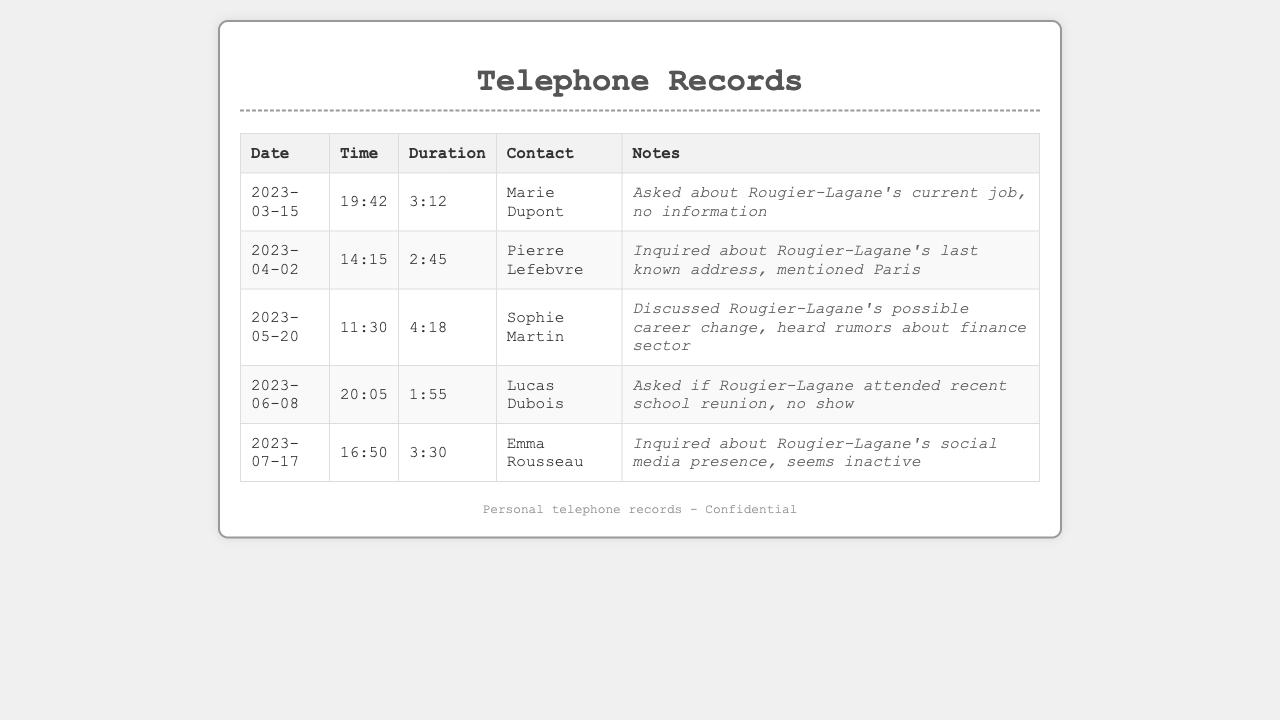What is the date of the first call? The first call recorded in the document was made on March 15, 2023.
Answer: March 15, 2023 Who was contacted on April 2, 2023? The contact on April 2, 2023, was Pierre Lefebvre.
Answer: Pierre Lefebvre What was the duration of the call with Sophie Martin? The call with Sophie Martin lasted for 4 minutes and 18 seconds.
Answer: 4:18 What did Emma Rousseau say about Rougier-Lagane's online activity? Emma Rousseau mentioned that Rougier-Lagane seems inactive on social media.
Answer: inactive How many contacts were called regarding Rougier-Lagane? There were five contacts mentioned in relation to Rougier-Lagane.
Answer: five On which date did the call about a school reunion occur? The call inquiring about the school reunion occurred on June 8, 2023.
Answer: June 8, 2023 What was the main topic discussed during the call with Pierre Lefebvre? The main topic was Rougier-Lagane's last known address.
Answer: last known address Which contact discussed rumors about Rougier-Lagane's career change? Sophie Martin discussed rumors about Rougier-Lagane's career change.
Answer: Sophie Martin 